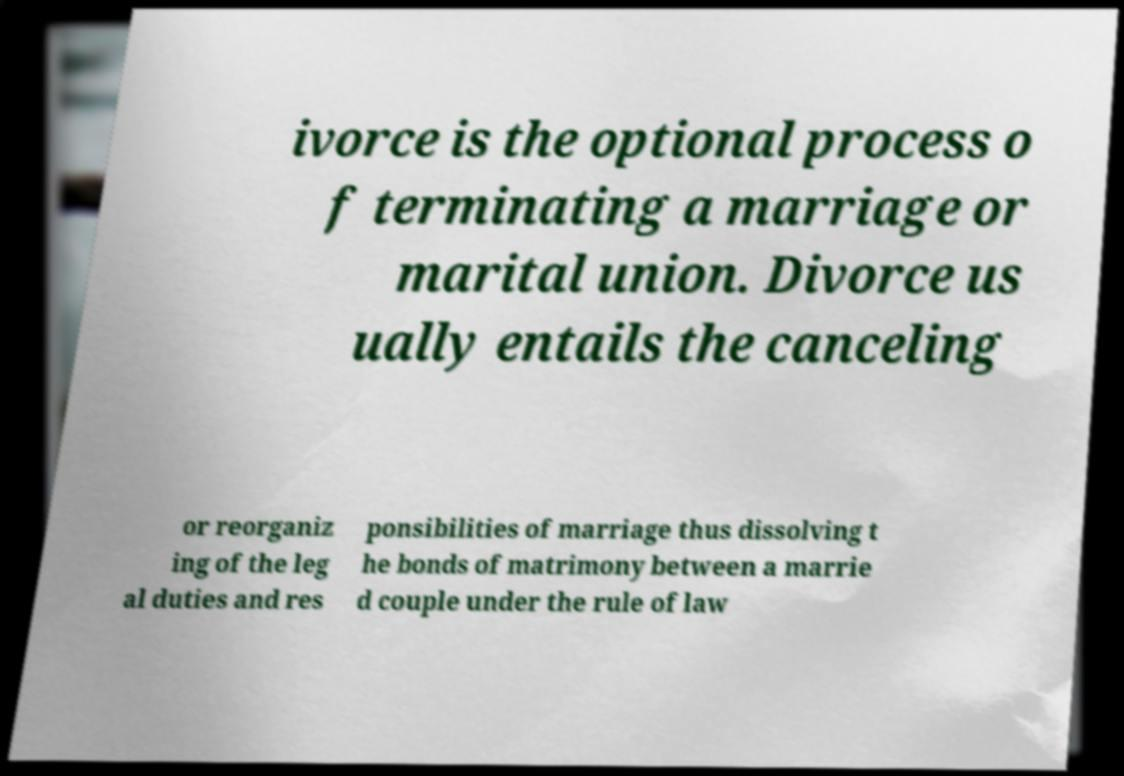Please read and relay the text visible in this image. What does it say? ivorce is the optional process o f terminating a marriage or marital union. Divorce us ually entails the canceling or reorganiz ing of the leg al duties and res ponsibilities of marriage thus dissolving t he bonds of matrimony between a marrie d couple under the rule of law 